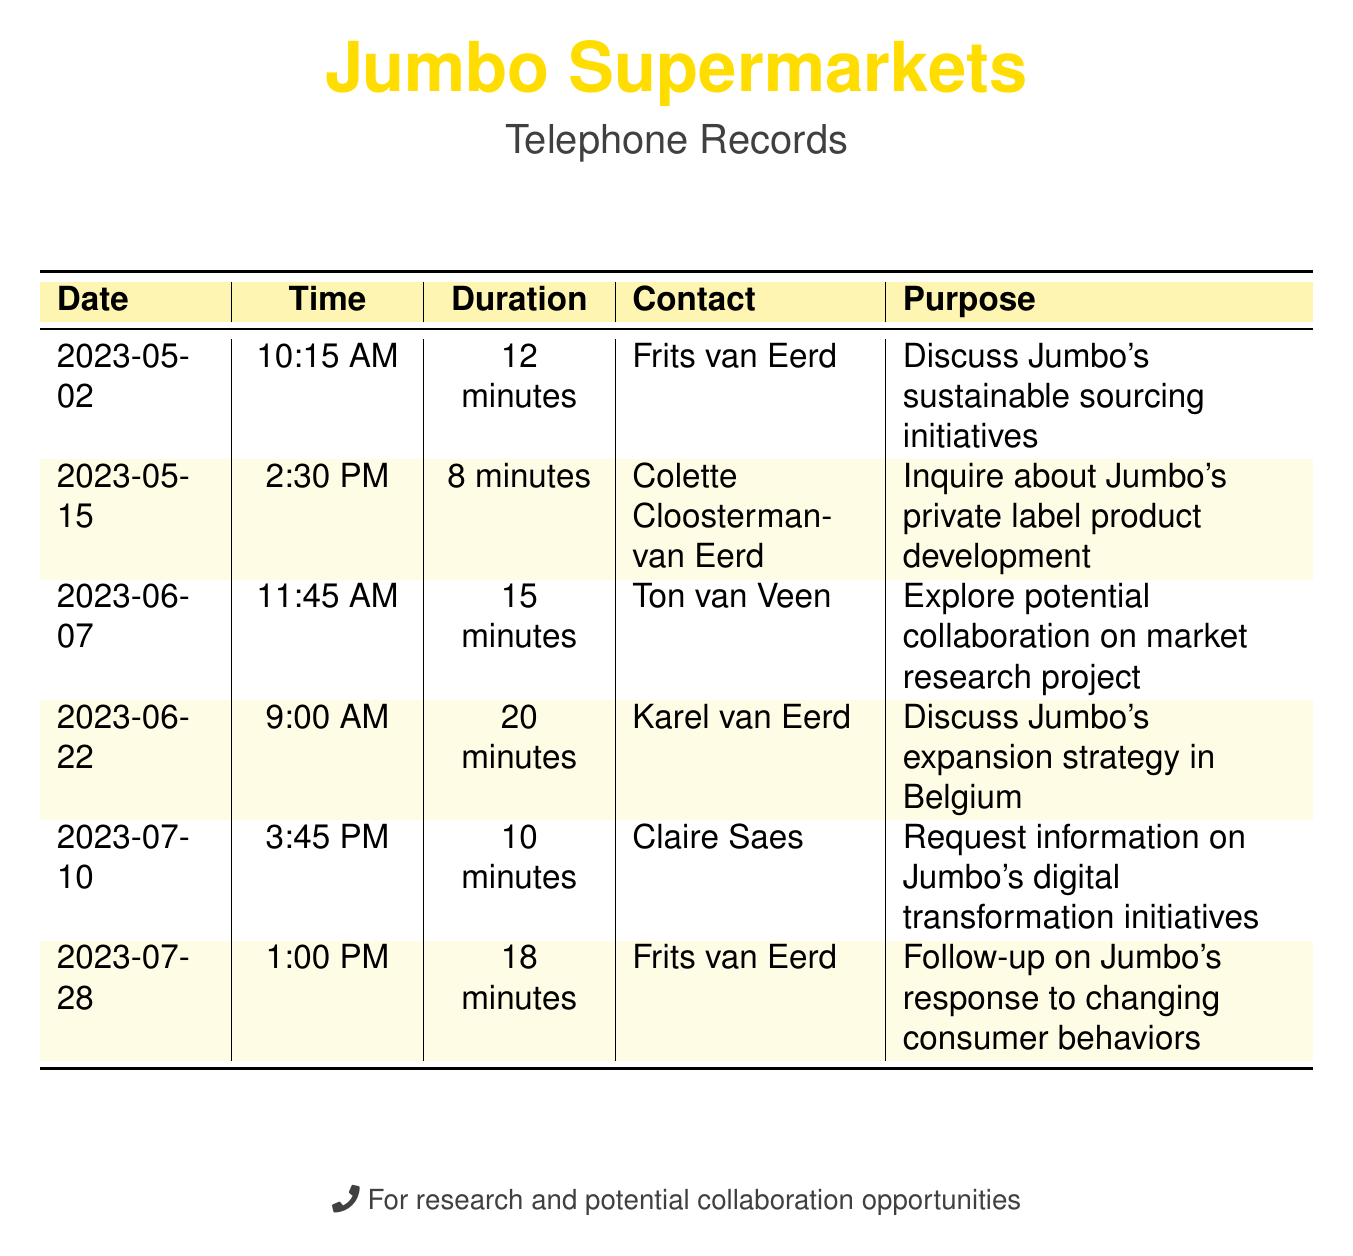What is the date of the call to Frits van Eerd? The date for the call to Frits van Eerd mentioned in the document is 2023-05-02.
Answer: 2023-05-02 How long was the call with Colette Cloosterman-van Eerd? The duration for the call with Colette Cloosterman-van Eerd is listed as 8 minutes.
Answer: 8 minutes What was the purpose of the call on June 7? The purpose of the call on June 7 is to explore potential collaboration on a market research project.
Answer: Explore potential collaboration on market research project Who called on July 10? The caller on July 10 is Claire Saes.
Answer: Claire Saes How many minutes did Frits van Eerd spend on the follow-up call? The follow-up call's duration with Frits van Eerd is recorded as 18 minutes.
Answer: 18 minutes What was discussed during the call on June 22? The discussion during the call on June 22 was about Jumbo's expansion strategy in Belgium.
Answer: Discuss Jumbo's expansion strategy in Belgium Which month had two calls listed in the document? The month with two calls is July, with calls on the 10th and the 28th.
Answer: July What is the longest call duration in the records? The longest call duration recorded is 20 minutes.
Answer: 20 minutes What does the footnote in the document indicate? The footnote indicates that the records are for research and potential collaboration opportunities.
Answer: For research and potential collaboration opportunities 